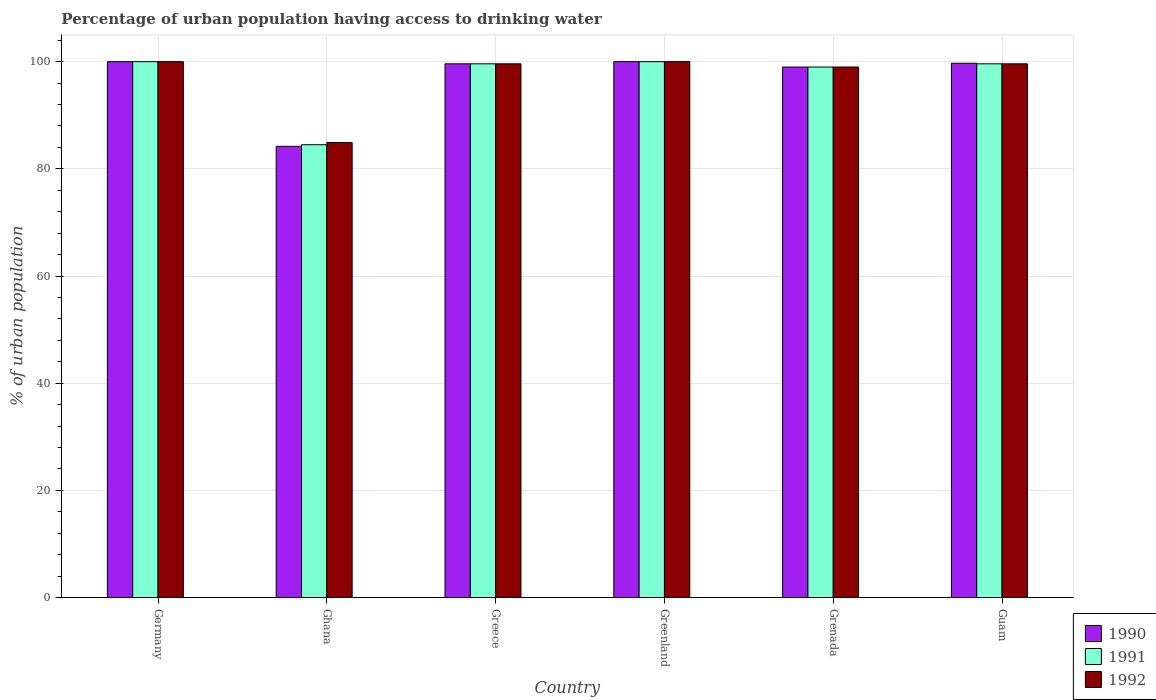Are the number of bars per tick equal to the number of legend labels?
Ensure brevity in your answer.  Yes. How many bars are there on the 2nd tick from the right?
Offer a very short reply. 3. What is the label of the 1st group of bars from the left?
Your response must be concise. Germany. In how many cases, is the number of bars for a given country not equal to the number of legend labels?
Offer a very short reply. 0. What is the percentage of urban population having access to drinking water in 1990 in Guam?
Offer a terse response. 99.7. Across all countries, what is the minimum percentage of urban population having access to drinking water in 1992?
Your answer should be very brief. 84.9. In which country was the percentage of urban population having access to drinking water in 1992 maximum?
Give a very brief answer. Germany. In which country was the percentage of urban population having access to drinking water in 1991 minimum?
Your answer should be compact. Ghana. What is the total percentage of urban population having access to drinking water in 1991 in the graph?
Keep it short and to the point. 582.7. What is the difference between the percentage of urban population having access to drinking water in 1990 in Germany and that in Guam?
Provide a short and direct response. 0.3. What is the difference between the percentage of urban population having access to drinking water in 1991 in Grenada and the percentage of urban population having access to drinking water in 1990 in Greenland?
Offer a very short reply. -1. What is the average percentage of urban population having access to drinking water in 1990 per country?
Your response must be concise. 97.08. What is the difference between the percentage of urban population having access to drinking water of/in 1992 and percentage of urban population having access to drinking water of/in 1991 in Greece?
Provide a short and direct response. 0. In how many countries, is the percentage of urban population having access to drinking water in 1991 greater than 72 %?
Give a very brief answer. 6. What is the ratio of the percentage of urban population having access to drinking water in 1991 in Ghana to that in Grenada?
Provide a short and direct response. 0.85. Is the difference between the percentage of urban population having access to drinking water in 1992 in Greece and Guam greater than the difference between the percentage of urban population having access to drinking water in 1991 in Greece and Guam?
Your answer should be compact. No. What is the difference between the highest and the second highest percentage of urban population having access to drinking water in 1992?
Your answer should be very brief. -0.4. What is the difference between the highest and the lowest percentage of urban population having access to drinking water in 1992?
Your answer should be compact. 15.1. Is the sum of the percentage of urban population having access to drinking water in 1992 in Ghana and Greenland greater than the maximum percentage of urban population having access to drinking water in 1991 across all countries?
Your answer should be very brief. Yes. What does the 3rd bar from the left in Grenada represents?
Your answer should be very brief. 1992. How many bars are there?
Provide a short and direct response. 18. How many countries are there in the graph?
Your response must be concise. 6. What is the difference between two consecutive major ticks on the Y-axis?
Ensure brevity in your answer.  20. Does the graph contain any zero values?
Make the answer very short. No. Does the graph contain grids?
Your answer should be compact. Yes. Where does the legend appear in the graph?
Your response must be concise. Bottom right. How many legend labels are there?
Ensure brevity in your answer.  3. How are the legend labels stacked?
Offer a terse response. Vertical. What is the title of the graph?
Provide a short and direct response. Percentage of urban population having access to drinking water. Does "1984" appear as one of the legend labels in the graph?
Offer a very short reply. No. What is the label or title of the Y-axis?
Your answer should be very brief. % of urban population. What is the % of urban population in 1990 in Ghana?
Provide a succinct answer. 84.2. What is the % of urban population of 1991 in Ghana?
Make the answer very short. 84.5. What is the % of urban population of 1992 in Ghana?
Ensure brevity in your answer.  84.9. What is the % of urban population of 1990 in Greece?
Provide a short and direct response. 99.6. What is the % of urban population in 1991 in Greece?
Your answer should be compact. 99.6. What is the % of urban population in 1992 in Greece?
Offer a terse response. 99.6. What is the % of urban population of 1990 in Greenland?
Provide a succinct answer. 100. What is the % of urban population of 1991 in Greenland?
Offer a very short reply. 100. What is the % of urban population in 1991 in Grenada?
Keep it short and to the point. 99. What is the % of urban population of 1992 in Grenada?
Provide a succinct answer. 99. What is the % of urban population of 1990 in Guam?
Your answer should be very brief. 99.7. What is the % of urban population in 1991 in Guam?
Ensure brevity in your answer.  99.6. What is the % of urban population of 1992 in Guam?
Provide a succinct answer. 99.6. Across all countries, what is the minimum % of urban population in 1990?
Make the answer very short. 84.2. Across all countries, what is the minimum % of urban population in 1991?
Ensure brevity in your answer.  84.5. Across all countries, what is the minimum % of urban population of 1992?
Provide a short and direct response. 84.9. What is the total % of urban population of 1990 in the graph?
Your response must be concise. 582.5. What is the total % of urban population of 1991 in the graph?
Your response must be concise. 582.7. What is the total % of urban population in 1992 in the graph?
Give a very brief answer. 583.1. What is the difference between the % of urban population of 1991 in Germany and that in Ghana?
Provide a short and direct response. 15.5. What is the difference between the % of urban population in 1990 in Germany and that in Greenland?
Give a very brief answer. 0. What is the difference between the % of urban population in 1991 in Germany and that in Greenland?
Your response must be concise. 0. What is the difference between the % of urban population in 1992 in Germany and that in Greenland?
Offer a terse response. 0. What is the difference between the % of urban population of 1992 in Germany and that in Grenada?
Your answer should be very brief. 1. What is the difference between the % of urban population of 1990 in Germany and that in Guam?
Offer a very short reply. 0.3. What is the difference between the % of urban population in 1991 in Germany and that in Guam?
Offer a terse response. 0.4. What is the difference between the % of urban population of 1992 in Germany and that in Guam?
Make the answer very short. 0.4. What is the difference between the % of urban population in 1990 in Ghana and that in Greece?
Your response must be concise. -15.4. What is the difference between the % of urban population in 1991 in Ghana and that in Greece?
Offer a terse response. -15.1. What is the difference between the % of urban population of 1992 in Ghana and that in Greece?
Give a very brief answer. -14.7. What is the difference between the % of urban population of 1990 in Ghana and that in Greenland?
Keep it short and to the point. -15.8. What is the difference between the % of urban population of 1991 in Ghana and that in Greenland?
Offer a very short reply. -15.5. What is the difference between the % of urban population in 1992 in Ghana and that in Greenland?
Keep it short and to the point. -15.1. What is the difference between the % of urban population in 1990 in Ghana and that in Grenada?
Offer a very short reply. -14.8. What is the difference between the % of urban population in 1991 in Ghana and that in Grenada?
Offer a very short reply. -14.5. What is the difference between the % of urban population in 1992 in Ghana and that in Grenada?
Offer a terse response. -14.1. What is the difference between the % of urban population in 1990 in Ghana and that in Guam?
Your answer should be compact. -15.5. What is the difference between the % of urban population of 1991 in Ghana and that in Guam?
Make the answer very short. -15.1. What is the difference between the % of urban population in 1992 in Ghana and that in Guam?
Keep it short and to the point. -14.7. What is the difference between the % of urban population of 1990 in Greece and that in Greenland?
Provide a short and direct response. -0.4. What is the difference between the % of urban population in 1992 in Greece and that in Greenland?
Give a very brief answer. -0.4. What is the difference between the % of urban population in 1991 in Greece and that in Grenada?
Your response must be concise. 0.6. What is the difference between the % of urban population in 1991 in Greece and that in Guam?
Provide a short and direct response. 0. What is the difference between the % of urban population of 1991 in Greenland and that in Grenada?
Ensure brevity in your answer.  1. What is the difference between the % of urban population of 1992 in Greenland and that in Grenada?
Give a very brief answer. 1. What is the difference between the % of urban population of 1992 in Greenland and that in Guam?
Your answer should be compact. 0.4. What is the difference between the % of urban population in 1991 in Grenada and that in Guam?
Keep it short and to the point. -0.6. What is the difference between the % of urban population in 1990 in Germany and the % of urban population in 1991 in Ghana?
Your response must be concise. 15.5. What is the difference between the % of urban population of 1991 in Germany and the % of urban population of 1992 in Ghana?
Your answer should be compact. 15.1. What is the difference between the % of urban population of 1991 in Germany and the % of urban population of 1992 in Greece?
Offer a very short reply. 0.4. What is the difference between the % of urban population in 1990 in Germany and the % of urban population in 1991 in Greenland?
Your answer should be compact. 0. What is the difference between the % of urban population in 1990 in Germany and the % of urban population in 1992 in Greenland?
Your response must be concise. 0. What is the difference between the % of urban population in 1991 in Germany and the % of urban population in 1992 in Grenada?
Your answer should be compact. 1. What is the difference between the % of urban population in 1990 in Germany and the % of urban population in 1991 in Guam?
Offer a terse response. 0.4. What is the difference between the % of urban population in 1991 in Germany and the % of urban population in 1992 in Guam?
Your answer should be very brief. 0.4. What is the difference between the % of urban population of 1990 in Ghana and the % of urban population of 1991 in Greece?
Offer a terse response. -15.4. What is the difference between the % of urban population in 1990 in Ghana and the % of urban population in 1992 in Greece?
Your response must be concise. -15.4. What is the difference between the % of urban population of 1991 in Ghana and the % of urban population of 1992 in Greece?
Provide a succinct answer. -15.1. What is the difference between the % of urban population of 1990 in Ghana and the % of urban population of 1991 in Greenland?
Your answer should be compact. -15.8. What is the difference between the % of urban population in 1990 in Ghana and the % of urban population in 1992 in Greenland?
Your answer should be very brief. -15.8. What is the difference between the % of urban population of 1991 in Ghana and the % of urban population of 1992 in Greenland?
Keep it short and to the point. -15.5. What is the difference between the % of urban population in 1990 in Ghana and the % of urban population in 1991 in Grenada?
Your answer should be very brief. -14.8. What is the difference between the % of urban population in 1990 in Ghana and the % of urban population in 1992 in Grenada?
Your answer should be compact. -14.8. What is the difference between the % of urban population in 1991 in Ghana and the % of urban population in 1992 in Grenada?
Your answer should be very brief. -14.5. What is the difference between the % of urban population of 1990 in Ghana and the % of urban population of 1991 in Guam?
Provide a short and direct response. -15.4. What is the difference between the % of urban population in 1990 in Ghana and the % of urban population in 1992 in Guam?
Your answer should be very brief. -15.4. What is the difference between the % of urban population in 1991 in Ghana and the % of urban population in 1992 in Guam?
Your answer should be very brief. -15.1. What is the difference between the % of urban population in 1990 in Greece and the % of urban population in 1992 in Greenland?
Give a very brief answer. -0.4. What is the difference between the % of urban population of 1991 in Greece and the % of urban population of 1992 in Greenland?
Provide a succinct answer. -0.4. What is the difference between the % of urban population of 1990 in Greece and the % of urban population of 1992 in Grenada?
Your answer should be very brief. 0.6. What is the difference between the % of urban population in 1991 in Greece and the % of urban population in 1992 in Grenada?
Ensure brevity in your answer.  0.6. What is the difference between the % of urban population in 1990 in Greece and the % of urban population in 1991 in Guam?
Your response must be concise. 0. What is the difference between the % of urban population of 1990 in Greenland and the % of urban population of 1991 in Grenada?
Ensure brevity in your answer.  1. What is the difference between the % of urban population of 1991 in Greenland and the % of urban population of 1992 in Grenada?
Your answer should be compact. 1. What is the difference between the % of urban population of 1991 in Greenland and the % of urban population of 1992 in Guam?
Give a very brief answer. 0.4. What is the difference between the % of urban population in 1991 in Grenada and the % of urban population in 1992 in Guam?
Keep it short and to the point. -0.6. What is the average % of urban population in 1990 per country?
Provide a succinct answer. 97.08. What is the average % of urban population in 1991 per country?
Ensure brevity in your answer.  97.12. What is the average % of urban population of 1992 per country?
Give a very brief answer. 97.18. What is the difference between the % of urban population in 1990 and % of urban population in 1991 in Germany?
Provide a succinct answer. 0. What is the difference between the % of urban population in 1991 and % of urban population in 1992 in Germany?
Your answer should be very brief. 0. What is the difference between the % of urban population in 1990 and % of urban population in 1991 in Ghana?
Ensure brevity in your answer.  -0.3. What is the difference between the % of urban population in 1991 and % of urban population in 1992 in Ghana?
Your answer should be compact. -0.4. What is the difference between the % of urban population in 1990 and % of urban population in 1991 in Greece?
Offer a very short reply. 0. What is the difference between the % of urban population in 1991 and % of urban population in 1992 in Greece?
Provide a short and direct response. 0. What is the difference between the % of urban population of 1990 and % of urban population of 1992 in Greenland?
Ensure brevity in your answer.  0. What is the difference between the % of urban population in 1991 and % of urban population in 1992 in Greenland?
Provide a short and direct response. 0. What is the difference between the % of urban population in 1990 and % of urban population in 1991 in Grenada?
Ensure brevity in your answer.  0. What is the difference between the % of urban population in 1991 and % of urban population in 1992 in Grenada?
Offer a very short reply. 0. What is the difference between the % of urban population in 1990 and % of urban population in 1991 in Guam?
Your answer should be compact. 0.1. What is the difference between the % of urban population of 1990 and % of urban population of 1992 in Guam?
Keep it short and to the point. 0.1. What is the ratio of the % of urban population of 1990 in Germany to that in Ghana?
Give a very brief answer. 1.19. What is the ratio of the % of urban population in 1991 in Germany to that in Ghana?
Provide a short and direct response. 1.18. What is the ratio of the % of urban population of 1992 in Germany to that in Ghana?
Offer a very short reply. 1.18. What is the ratio of the % of urban population in 1991 in Germany to that in Greece?
Offer a terse response. 1. What is the ratio of the % of urban population of 1990 in Germany to that in Grenada?
Your answer should be compact. 1.01. What is the ratio of the % of urban population of 1991 in Germany to that in Grenada?
Ensure brevity in your answer.  1.01. What is the ratio of the % of urban population of 1990 in Ghana to that in Greece?
Your response must be concise. 0.85. What is the ratio of the % of urban population in 1991 in Ghana to that in Greece?
Keep it short and to the point. 0.85. What is the ratio of the % of urban population in 1992 in Ghana to that in Greece?
Provide a succinct answer. 0.85. What is the ratio of the % of urban population of 1990 in Ghana to that in Greenland?
Provide a succinct answer. 0.84. What is the ratio of the % of urban population of 1991 in Ghana to that in Greenland?
Your answer should be compact. 0.84. What is the ratio of the % of urban population of 1992 in Ghana to that in Greenland?
Keep it short and to the point. 0.85. What is the ratio of the % of urban population of 1990 in Ghana to that in Grenada?
Keep it short and to the point. 0.85. What is the ratio of the % of urban population in 1991 in Ghana to that in Grenada?
Ensure brevity in your answer.  0.85. What is the ratio of the % of urban population in 1992 in Ghana to that in Grenada?
Offer a very short reply. 0.86. What is the ratio of the % of urban population of 1990 in Ghana to that in Guam?
Ensure brevity in your answer.  0.84. What is the ratio of the % of urban population in 1991 in Ghana to that in Guam?
Make the answer very short. 0.85. What is the ratio of the % of urban population of 1992 in Ghana to that in Guam?
Provide a succinct answer. 0.85. What is the ratio of the % of urban population in 1990 in Greece to that in Greenland?
Make the answer very short. 1. What is the ratio of the % of urban population in 1991 in Greece to that in Greenland?
Offer a very short reply. 1. What is the ratio of the % of urban population in 1990 in Greece to that in Grenada?
Make the answer very short. 1.01. What is the ratio of the % of urban population in 1992 in Greece to that in Grenada?
Your response must be concise. 1.01. What is the ratio of the % of urban population of 1992 in Greece to that in Guam?
Provide a succinct answer. 1. What is the ratio of the % of urban population in 1990 in Greenland to that in Grenada?
Offer a very short reply. 1.01. What is the ratio of the % of urban population in 1991 in Greenland to that in Grenada?
Your answer should be very brief. 1.01. What is the ratio of the % of urban population in 1990 in Greenland to that in Guam?
Offer a terse response. 1. What is the ratio of the % of urban population in 1991 in Greenland to that in Guam?
Provide a succinct answer. 1. What is the ratio of the % of urban population of 1992 in Greenland to that in Guam?
Provide a short and direct response. 1. What is the ratio of the % of urban population of 1990 in Grenada to that in Guam?
Keep it short and to the point. 0.99. What is the ratio of the % of urban population of 1991 in Grenada to that in Guam?
Keep it short and to the point. 0.99. What is the difference between the highest and the lowest % of urban population of 1990?
Provide a succinct answer. 15.8. What is the difference between the highest and the lowest % of urban population in 1991?
Offer a terse response. 15.5. What is the difference between the highest and the lowest % of urban population in 1992?
Provide a short and direct response. 15.1. 